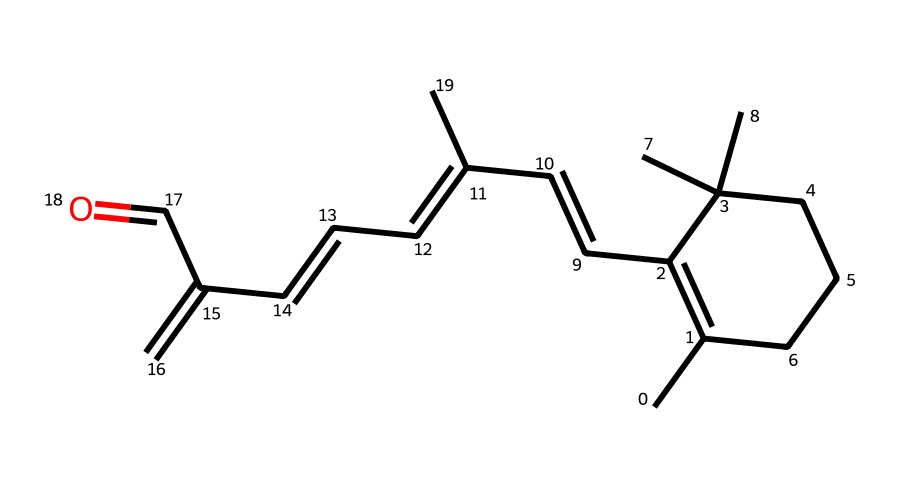what is the molecular formula of retinol? To find the molecular formula, we count the carbon (C), hydrogen (H), and oxygen (O) atoms present in the chemical structure represented by the SMILES. From the structure, we identify that there are 20 carbon atoms, 30 hydrogen atoms, and 1 oxygen atom, leading to the formula C20H30O.
Answer: C20H30O how many rings are in this chemical structure? We examine the SMILES representation to identify any cyclic structures. The notation indicates that there is one ring in the chemical structure. Therefore, the answer is one.
Answer: one is retinol an aliphatic compound? Aliphatic compounds are characterized by having carbon atoms linked in open chains or branched structures, as seen in the provided SMILES representation of retinol. Since it doesn't have any aromatic rings and fits this definition, retinol is indeed considered aliphatic.
Answer: yes what type of functional group does retinol contain? By analyzing the chemical structure, we identify the aldehyde group (-CHO) at the end of the carbon chain, indicated by the presence of the carbonyl group followed by a hydrogen atom. This identifies the functional group present in retinol.
Answer: aldehyde how many double bonds are present in retinol? To determine the number of double bonds, we can look for the unsaturated carbon-carbon bonds in the structure. Upon reviewing the SMILES representation, we can identify a total of 5 double bonds present.
Answer: 5 which part of retinol contributes to its vitamin A activity? The structure indicates a specific configuration of the aldehyde functional group along with the long carbon chain; together, these components, particularly the β-ionone ring structure and the aldehyde, are critical for its biologically active properties as vitamin A.
Answer: β-ionone ring 